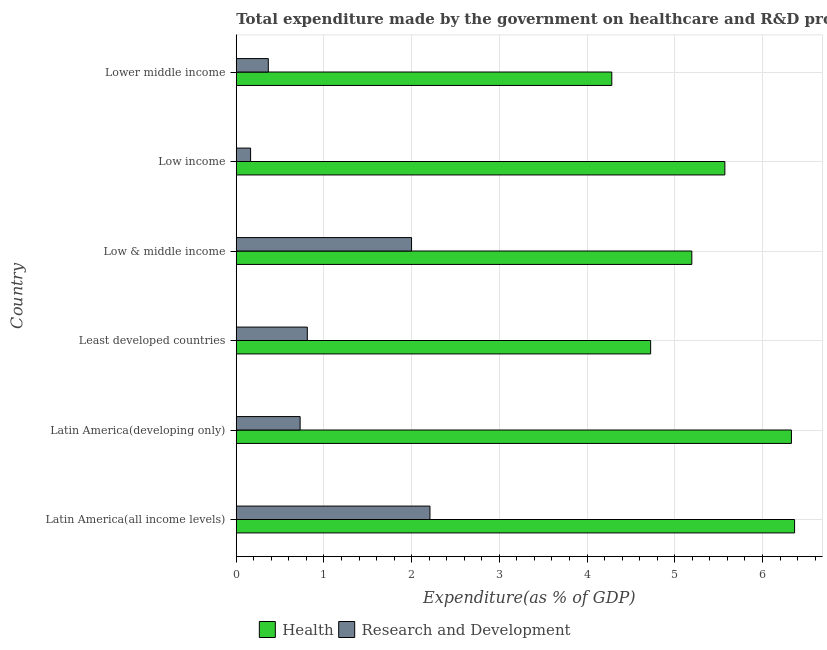How many bars are there on the 1st tick from the top?
Give a very brief answer. 2. What is the label of the 5th group of bars from the top?
Provide a succinct answer. Latin America(developing only). What is the expenditure in r&d in Latin America(developing only)?
Make the answer very short. 0.73. Across all countries, what is the maximum expenditure in r&d?
Provide a short and direct response. 2.21. Across all countries, what is the minimum expenditure in healthcare?
Your answer should be compact. 4.28. In which country was the expenditure in healthcare maximum?
Provide a succinct answer. Latin America(all income levels). In which country was the expenditure in healthcare minimum?
Give a very brief answer. Lower middle income. What is the total expenditure in healthcare in the graph?
Provide a succinct answer. 32.47. What is the difference between the expenditure in r&d in Low income and that in Lower middle income?
Ensure brevity in your answer.  -0.2. What is the difference between the expenditure in r&d in Lower middle income and the expenditure in healthcare in Latin America(all income levels)?
Provide a short and direct response. -6. What is the average expenditure in healthcare per country?
Offer a very short reply. 5.41. What is the difference between the expenditure in healthcare and expenditure in r&d in Latin America(all income levels)?
Your answer should be compact. 4.16. What is the ratio of the expenditure in healthcare in Low income to that in Lower middle income?
Provide a short and direct response. 1.3. What is the difference between the highest and the second highest expenditure in healthcare?
Provide a short and direct response. 0.04. What is the difference between the highest and the lowest expenditure in r&d?
Your answer should be very brief. 2.05. Is the sum of the expenditure in healthcare in Least developed countries and Low & middle income greater than the maximum expenditure in r&d across all countries?
Offer a very short reply. Yes. What does the 2nd bar from the top in Latin America(developing only) represents?
Offer a very short reply. Health. What does the 1st bar from the bottom in Least developed countries represents?
Your answer should be compact. Health. How many bars are there?
Provide a short and direct response. 12. What is the difference between two consecutive major ticks on the X-axis?
Provide a succinct answer. 1. Are the values on the major ticks of X-axis written in scientific E-notation?
Keep it short and to the point. No. Does the graph contain any zero values?
Offer a very short reply. No. How many legend labels are there?
Make the answer very short. 2. What is the title of the graph?
Provide a short and direct response. Total expenditure made by the government on healthcare and R&D projects in 2004. What is the label or title of the X-axis?
Provide a short and direct response. Expenditure(as % of GDP). What is the Expenditure(as % of GDP) in Health in Latin America(all income levels)?
Your response must be concise. 6.37. What is the Expenditure(as % of GDP) of Research and Development in Latin America(all income levels)?
Offer a very short reply. 2.21. What is the Expenditure(as % of GDP) in Health in Latin America(developing only)?
Offer a terse response. 6.33. What is the Expenditure(as % of GDP) of Research and Development in Latin America(developing only)?
Provide a succinct answer. 0.73. What is the Expenditure(as % of GDP) of Health in Least developed countries?
Make the answer very short. 4.72. What is the Expenditure(as % of GDP) in Research and Development in Least developed countries?
Make the answer very short. 0.81. What is the Expenditure(as % of GDP) in Health in Low & middle income?
Give a very brief answer. 5.19. What is the Expenditure(as % of GDP) in Research and Development in Low & middle income?
Provide a succinct answer. 2. What is the Expenditure(as % of GDP) of Health in Low income?
Offer a very short reply. 5.57. What is the Expenditure(as % of GDP) in Research and Development in Low income?
Your answer should be compact. 0.16. What is the Expenditure(as % of GDP) in Health in Lower middle income?
Ensure brevity in your answer.  4.28. What is the Expenditure(as % of GDP) in Research and Development in Lower middle income?
Provide a succinct answer. 0.37. Across all countries, what is the maximum Expenditure(as % of GDP) in Health?
Provide a succinct answer. 6.37. Across all countries, what is the maximum Expenditure(as % of GDP) in Research and Development?
Provide a short and direct response. 2.21. Across all countries, what is the minimum Expenditure(as % of GDP) of Health?
Provide a succinct answer. 4.28. Across all countries, what is the minimum Expenditure(as % of GDP) of Research and Development?
Your answer should be very brief. 0.16. What is the total Expenditure(as % of GDP) of Health in the graph?
Your answer should be very brief. 32.47. What is the total Expenditure(as % of GDP) in Research and Development in the graph?
Give a very brief answer. 6.28. What is the difference between the Expenditure(as % of GDP) in Health in Latin America(all income levels) and that in Latin America(developing only)?
Your answer should be very brief. 0.04. What is the difference between the Expenditure(as % of GDP) of Research and Development in Latin America(all income levels) and that in Latin America(developing only)?
Keep it short and to the point. 1.48. What is the difference between the Expenditure(as % of GDP) in Health in Latin America(all income levels) and that in Least developed countries?
Keep it short and to the point. 1.64. What is the difference between the Expenditure(as % of GDP) of Research and Development in Latin America(all income levels) and that in Least developed countries?
Your answer should be very brief. 1.4. What is the difference between the Expenditure(as % of GDP) in Health in Latin America(all income levels) and that in Low & middle income?
Give a very brief answer. 1.17. What is the difference between the Expenditure(as % of GDP) of Research and Development in Latin America(all income levels) and that in Low & middle income?
Keep it short and to the point. 0.21. What is the difference between the Expenditure(as % of GDP) of Health in Latin America(all income levels) and that in Low income?
Provide a short and direct response. 0.8. What is the difference between the Expenditure(as % of GDP) of Research and Development in Latin America(all income levels) and that in Low income?
Provide a short and direct response. 2.04. What is the difference between the Expenditure(as % of GDP) in Health in Latin America(all income levels) and that in Lower middle income?
Your response must be concise. 2.08. What is the difference between the Expenditure(as % of GDP) of Research and Development in Latin America(all income levels) and that in Lower middle income?
Make the answer very short. 1.84. What is the difference between the Expenditure(as % of GDP) of Health in Latin America(developing only) and that in Least developed countries?
Keep it short and to the point. 1.61. What is the difference between the Expenditure(as % of GDP) of Research and Development in Latin America(developing only) and that in Least developed countries?
Make the answer very short. -0.08. What is the difference between the Expenditure(as % of GDP) of Health in Latin America(developing only) and that in Low & middle income?
Provide a succinct answer. 1.14. What is the difference between the Expenditure(as % of GDP) in Research and Development in Latin America(developing only) and that in Low & middle income?
Your response must be concise. -1.27. What is the difference between the Expenditure(as % of GDP) of Health in Latin America(developing only) and that in Low income?
Ensure brevity in your answer.  0.76. What is the difference between the Expenditure(as % of GDP) of Research and Development in Latin America(developing only) and that in Low income?
Make the answer very short. 0.56. What is the difference between the Expenditure(as % of GDP) of Health in Latin America(developing only) and that in Lower middle income?
Your answer should be compact. 2.05. What is the difference between the Expenditure(as % of GDP) in Research and Development in Latin America(developing only) and that in Lower middle income?
Provide a short and direct response. 0.36. What is the difference between the Expenditure(as % of GDP) of Health in Least developed countries and that in Low & middle income?
Your answer should be very brief. -0.47. What is the difference between the Expenditure(as % of GDP) in Research and Development in Least developed countries and that in Low & middle income?
Make the answer very short. -1.19. What is the difference between the Expenditure(as % of GDP) of Health in Least developed countries and that in Low income?
Your response must be concise. -0.85. What is the difference between the Expenditure(as % of GDP) in Research and Development in Least developed countries and that in Low income?
Your answer should be very brief. 0.65. What is the difference between the Expenditure(as % of GDP) of Health in Least developed countries and that in Lower middle income?
Your answer should be very brief. 0.44. What is the difference between the Expenditure(as % of GDP) in Research and Development in Least developed countries and that in Lower middle income?
Provide a short and direct response. 0.44. What is the difference between the Expenditure(as % of GDP) in Health in Low & middle income and that in Low income?
Provide a succinct answer. -0.38. What is the difference between the Expenditure(as % of GDP) of Research and Development in Low & middle income and that in Low income?
Ensure brevity in your answer.  1.84. What is the difference between the Expenditure(as % of GDP) in Health in Low & middle income and that in Lower middle income?
Your answer should be compact. 0.91. What is the difference between the Expenditure(as % of GDP) of Research and Development in Low & middle income and that in Lower middle income?
Make the answer very short. 1.63. What is the difference between the Expenditure(as % of GDP) of Health in Low income and that in Lower middle income?
Make the answer very short. 1.29. What is the difference between the Expenditure(as % of GDP) in Research and Development in Low income and that in Lower middle income?
Give a very brief answer. -0.2. What is the difference between the Expenditure(as % of GDP) of Health in Latin America(all income levels) and the Expenditure(as % of GDP) of Research and Development in Latin America(developing only)?
Keep it short and to the point. 5.64. What is the difference between the Expenditure(as % of GDP) of Health in Latin America(all income levels) and the Expenditure(as % of GDP) of Research and Development in Least developed countries?
Keep it short and to the point. 5.56. What is the difference between the Expenditure(as % of GDP) in Health in Latin America(all income levels) and the Expenditure(as % of GDP) in Research and Development in Low & middle income?
Keep it short and to the point. 4.37. What is the difference between the Expenditure(as % of GDP) of Health in Latin America(all income levels) and the Expenditure(as % of GDP) of Research and Development in Low income?
Ensure brevity in your answer.  6.2. What is the difference between the Expenditure(as % of GDP) of Health in Latin America(all income levels) and the Expenditure(as % of GDP) of Research and Development in Lower middle income?
Ensure brevity in your answer.  6. What is the difference between the Expenditure(as % of GDP) of Health in Latin America(developing only) and the Expenditure(as % of GDP) of Research and Development in Least developed countries?
Give a very brief answer. 5.52. What is the difference between the Expenditure(as % of GDP) in Health in Latin America(developing only) and the Expenditure(as % of GDP) in Research and Development in Low & middle income?
Ensure brevity in your answer.  4.33. What is the difference between the Expenditure(as % of GDP) in Health in Latin America(developing only) and the Expenditure(as % of GDP) in Research and Development in Low income?
Offer a very short reply. 6.17. What is the difference between the Expenditure(as % of GDP) in Health in Latin America(developing only) and the Expenditure(as % of GDP) in Research and Development in Lower middle income?
Make the answer very short. 5.96. What is the difference between the Expenditure(as % of GDP) of Health in Least developed countries and the Expenditure(as % of GDP) of Research and Development in Low & middle income?
Your answer should be very brief. 2.73. What is the difference between the Expenditure(as % of GDP) of Health in Least developed countries and the Expenditure(as % of GDP) of Research and Development in Low income?
Ensure brevity in your answer.  4.56. What is the difference between the Expenditure(as % of GDP) of Health in Least developed countries and the Expenditure(as % of GDP) of Research and Development in Lower middle income?
Make the answer very short. 4.36. What is the difference between the Expenditure(as % of GDP) of Health in Low & middle income and the Expenditure(as % of GDP) of Research and Development in Low income?
Give a very brief answer. 5.03. What is the difference between the Expenditure(as % of GDP) in Health in Low & middle income and the Expenditure(as % of GDP) in Research and Development in Lower middle income?
Your answer should be very brief. 4.83. What is the difference between the Expenditure(as % of GDP) of Health in Low income and the Expenditure(as % of GDP) of Research and Development in Lower middle income?
Provide a short and direct response. 5.21. What is the average Expenditure(as % of GDP) in Health per country?
Your answer should be compact. 5.41. What is the average Expenditure(as % of GDP) of Research and Development per country?
Your response must be concise. 1.05. What is the difference between the Expenditure(as % of GDP) of Health and Expenditure(as % of GDP) of Research and Development in Latin America(all income levels)?
Keep it short and to the point. 4.16. What is the difference between the Expenditure(as % of GDP) in Health and Expenditure(as % of GDP) in Research and Development in Latin America(developing only)?
Offer a very short reply. 5.6. What is the difference between the Expenditure(as % of GDP) of Health and Expenditure(as % of GDP) of Research and Development in Least developed countries?
Keep it short and to the point. 3.91. What is the difference between the Expenditure(as % of GDP) in Health and Expenditure(as % of GDP) in Research and Development in Low & middle income?
Keep it short and to the point. 3.2. What is the difference between the Expenditure(as % of GDP) in Health and Expenditure(as % of GDP) in Research and Development in Low income?
Your answer should be very brief. 5.41. What is the difference between the Expenditure(as % of GDP) of Health and Expenditure(as % of GDP) of Research and Development in Lower middle income?
Give a very brief answer. 3.92. What is the ratio of the Expenditure(as % of GDP) of Health in Latin America(all income levels) to that in Latin America(developing only)?
Your response must be concise. 1.01. What is the ratio of the Expenditure(as % of GDP) of Research and Development in Latin America(all income levels) to that in Latin America(developing only)?
Your answer should be compact. 3.03. What is the ratio of the Expenditure(as % of GDP) of Health in Latin America(all income levels) to that in Least developed countries?
Make the answer very short. 1.35. What is the ratio of the Expenditure(as % of GDP) in Research and Development in Latin America(all income levels) to that in Least developed countries?
Give a very brief answer. 2.73. What is the ratio of the Expenditure(as % of GDP) in Health in Latin America(all income levels) to that in Low & middle income?
Your response must be concise. 1.23. What is the ratio of the Expenditure(as % of GDP) of Research and Development in Latin America(all income levels) to that in Low & middle income?
Offer a terse response. 1.1. What is the ratio of the Expenditure(as % of GDP) of Health in Latin America(all income levels) to that in Low income?
Provide a short and direct response. 1.14. What is the ratio of the Expenditure(as % of GDP) of Research and Development in Latin America(all income levels) to that in Low income?
Your response must be concise. 13.5. What is the ratio of the Expenditure(as % of GDP) in Health in Latin America(all income levels) to that in Lower middle income?
Make the answer very short. 1.49. What is the ratio of the Expenditure(as % of GDP) of Research and Development in Latin America(all income levels) to that in Lower middle income?
Your answer should be very brief. 6.04. What is the ratio of the Expenditure(as % of GDP) of Health in Latin America(developing only) to that in Least developed countries?
Offer a terse response. 1.34. What is the ratio of the Expenditure(as % of GDP) of Research and Development in Latin America(developing only) to that in Least developed countries?
Offer a terse response. 0.9. What is the ratio of the Expenditure(as % of GDP) in Health in Latin America(developing only) to that in Low & middle income?
Provide a short and direct response. 1.22. What is the ratio of the Expenditure(as % of GDP) of Research and Development in Latin America(developing only) to that in Low & middle income?
Offer a terse response. 0.36. What is the ratio of the Expenditure(as % of GDP) of Health in Latin America(developing only) to that in Low income?
Your answer should be very brief. 1.14. What is the ratio of the Expenditure(as % of GDP) of Research and Development in Latin America(developing only) to that in Low income?
Provide a succinct answer. 4.45. What is the ratio of the Expenditure(as % of GDP) of Health in Latin America(developing only) to that in Lower middle income?
Make the answer very short. 1.48. What is the ratio of the Expenditure(as % of GDP) in Research and Development in Latin America(developing only) to that in Lower middle income?
Ensure brevity in your answer.  1.99. What is the ratio of the Expenditure(as % of GDP) in Health in Least developed countries to that in Low & middle income?
Provide a short and direct response. 0.91. What is the ratio of the Expenditure(as % of GDP) of Research and Development in Least developed countries to that in Low & middle income?
Keep it short and to the point. 0.41. What is the ratio of the Expenditure(as % of GDP) in Health in Least developed countries to that in Low income?
Your answer should be compact. 0.85. What is the ratio of the Expenditure(as % of GDP) of Research and Development in Least developed countries to that in Low income?
Your answer should be very brief. 4.95. What is the ratio of the Expenditure(as % of GDP) in Health in Least developed countries to that in Lower middle income?
Give a very brief answer. 1.1. What is the ratio of the Expenditure(as % of GDP) in Research and Development in Least developed countries to that in Lower middle income?
Your response must be concise. 2.22. What is the ratio of the Expenditure(as % of GDP) in Health in Low & middle income to that in Low income?
Make the answer very short. 0.93. What is the ratio of the Expenditure(as % of GDP) of Research and Development in Low & middle income to that in Low income?
Provide a succinct answer. 12.22. What is the ratio of the Expenditure(as % of GDP) of Health in Low & middle income to that in Lower middle income?
Provide a succinct answer. 1.21. What is the ratio of the Expenditure(as % of GDP) of Research and Development in Low & middle income to that in Lower middle income?
Your response must be concise. 5.47. What is the ratio of the Expenditure(as % of GDP) of Health in Low income to that in Lower middle income?
Offer a very short reply. 1.3. What is the ratio of the Expenditure(as % of GDP) in Research and Development in Low income to that in Lower middle income?
Offer a very short reply. 0.45. What is the difference between the highest and the second highest Expenditure(as % of GDP) of Health?
Provide a succinct answer. 0.04. What is the difference between the highest and the second highest Expenditure(as % of GDP) in Research and Development?
Offer a very short reply. 0.21. What is the difference between the highest and the lowest Expenditure(as % of GDP) of Health?
Your answer should be very brief. 2.08. What is the difference between the highest and the lowest Expenditure(as % of GDP) of Research and Development?
Provide a short and direct response. 2.04. 